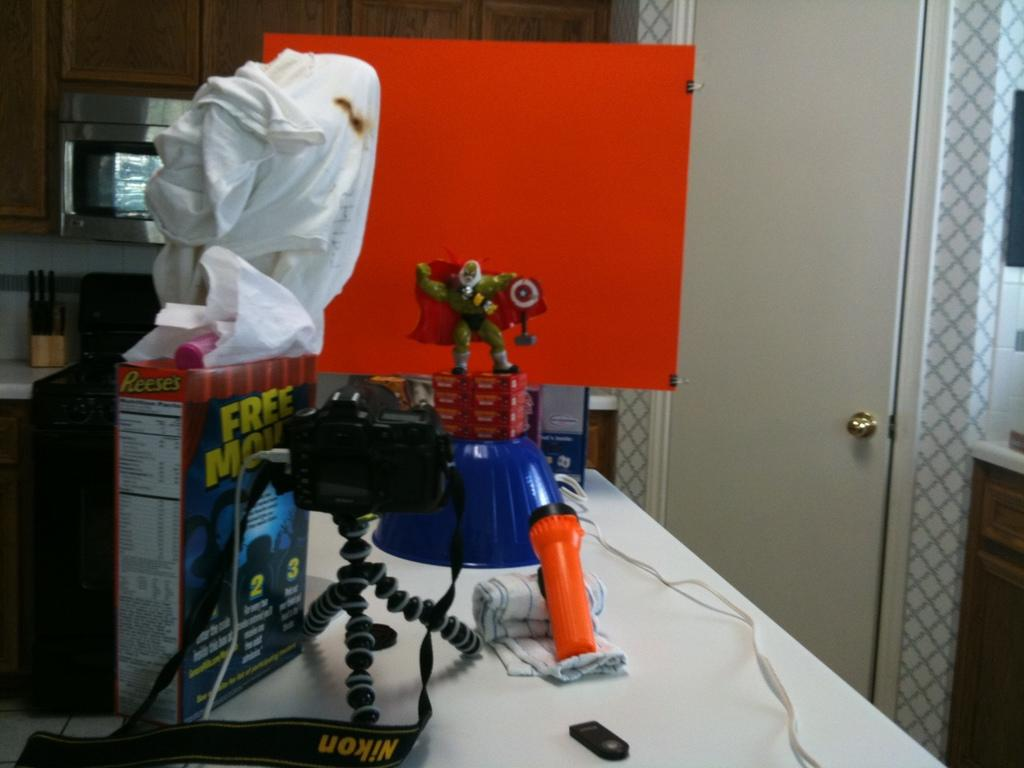What is the main object in the image? There is a camera in the image. What other objects can be seen in the image? There is an orange torch, a box, a toy, and objects on a white color table in the image. What colors are present in the image? The orange torch and an orange color board are present, along with objects on a white color table. What type of furniture is visible in the image? There is a white door, a cupboard, and an oven in the image. Are there any objects visible in the background of the image? Yes, there are objects visible at the back of the image. How many bottles of soda are on the table in the image? There is no mention of soda bottles in the image; only a camera, an orange torch, a box, a toy, and objects on a white color table are present. Is there a baby visible in the image? There is no baby present in the image. Are there any slaves depicted in the image? There is no reference to slavery or slaves in the image; it features a camera, an orange torch, a box, a toy, and objects on a white color table. 